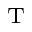<formula> <loc_0><loc_0><loc_500><loc_500>_ { T }</formula> 